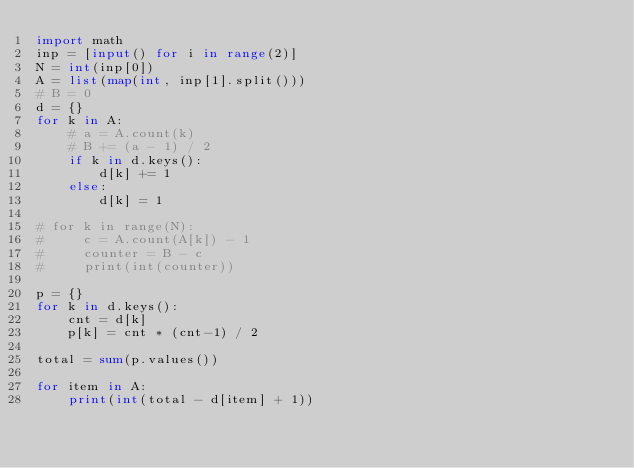<code> <loc_0><loc_0><loc_500><loc_500><_Python_>import math
inp = [input() for i in range(2)]
N = int(inp[0])
A = list(map(int, inp[1].split()))
# B = 0
d = {}
for k in A:
    # a = A.count(k)
    # B += (a - 1) / 2
    if k in d.keys():
        d[k] += 1
    else:
        d[k] = 1

# for k in range(N):
#     c = A.count(A[k]) - 1
#     counter = B - c
#     print(int(counter))

p = {}
for k in d.keys():
    cnt = d[k]
    p[k] = cnt * (cnt-1) / 2

total = sum(p.values())

for item in A:
    print(int(total - d[item] + 1))</code> 